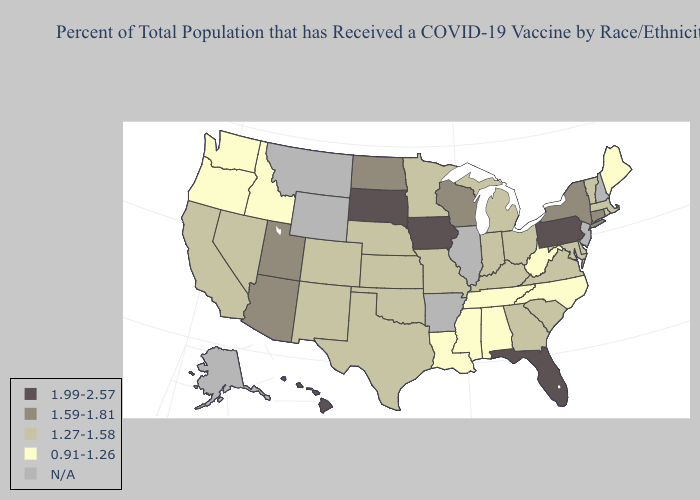Does Pennsylvania have the highest value in the USA?
Keep it brief. Yes. Does Vermont have the highest value in the Northeast?
Keep it brief. No. Does Maine have the lowest value in the Northeast?
Keep it brief. Yes. Does Mississippi have the highest value in the USA?
Concise answer only. No. Does Wisconsin have the lowest value in the MidWest?
Answer briefly. No. What is the value of Kentucky?
Concise answer only. 1.27-1.58. What is the value of Indiana?
Quick response, please. 1.27-1.58. What is the value of Oklahoma?
Short answer required. 1.27-1.58. How many symbols are there in the legend?
Quick response, please. 5. Name the states that have a value in the range 0.91-1.26?
Short answer required. Alabama, Idaho, Louisiana, Maine, Mississippi, North Carolina, Oregon, Tennessee, Washington, West Virginia. What is the value of Nevada?
Write a very short answer. 1.27-1.58. What is the lowest value in the West?
Short answer required. 0.91-1.26. What is the highest value in states that border Delaware?
Write a very short answer. 1.99-2.57. What is the highest value in states that border Washington?
Give a very brief answer. 0.91-1.26. 